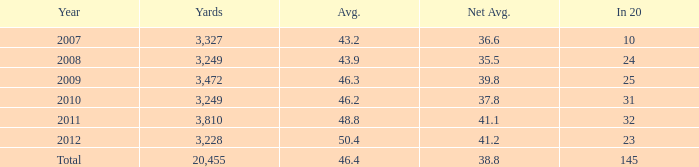How many yards are there in 32 when it is represented as 20 units? 1.0. 